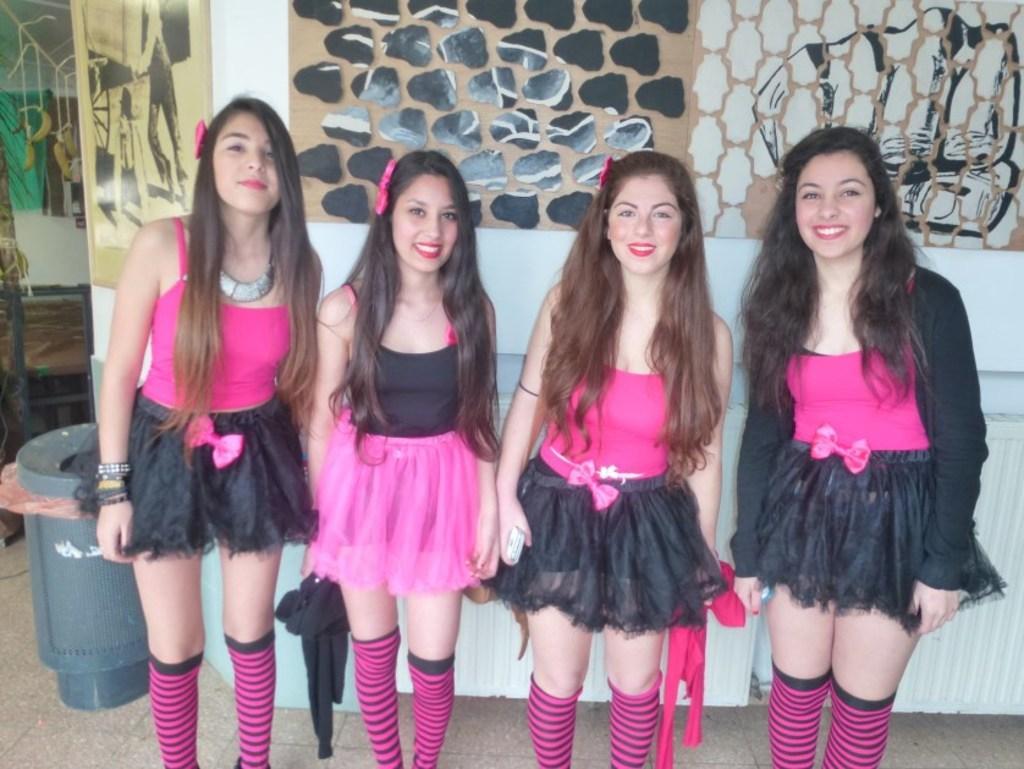Describe this image in one or two sentences. In this image there are four persons standing, there are truncated towards the bottom of the image, there are holding an object, at the background of the image there is a wall truncated, there is an object on the ground, there are objects on the wall, there are objects truncated truncated towards the top of the image, there are objects truncated towards the left of the image. 